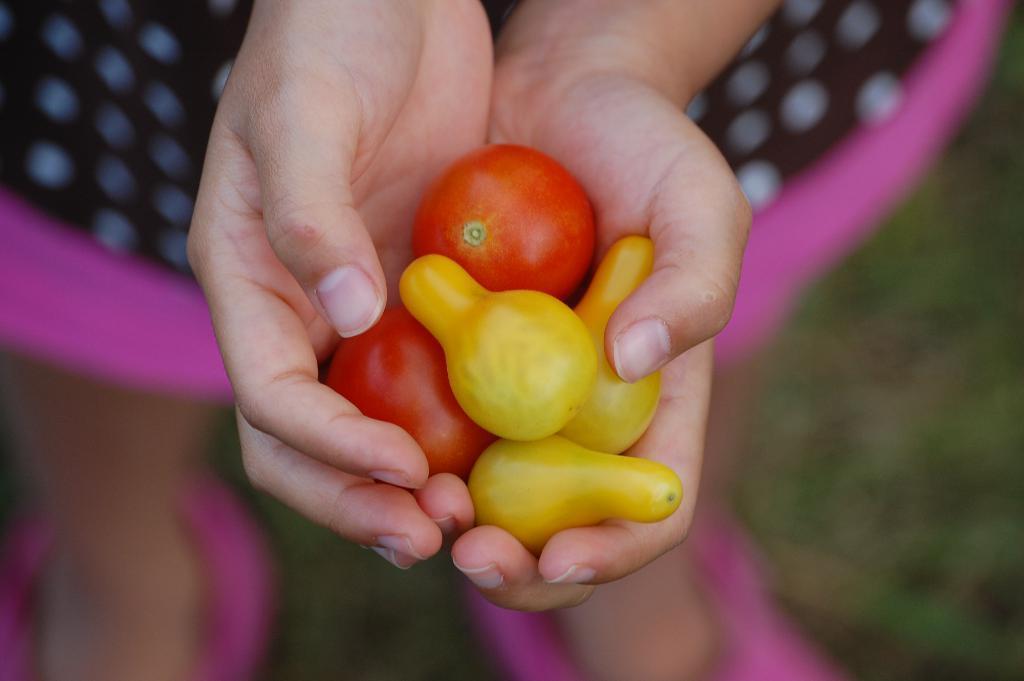In one or two sentences, can you explain what this image depicts? We can see a person is standing and holding tomatoes and other vegetable items in the hand. In the background the image is blur. 